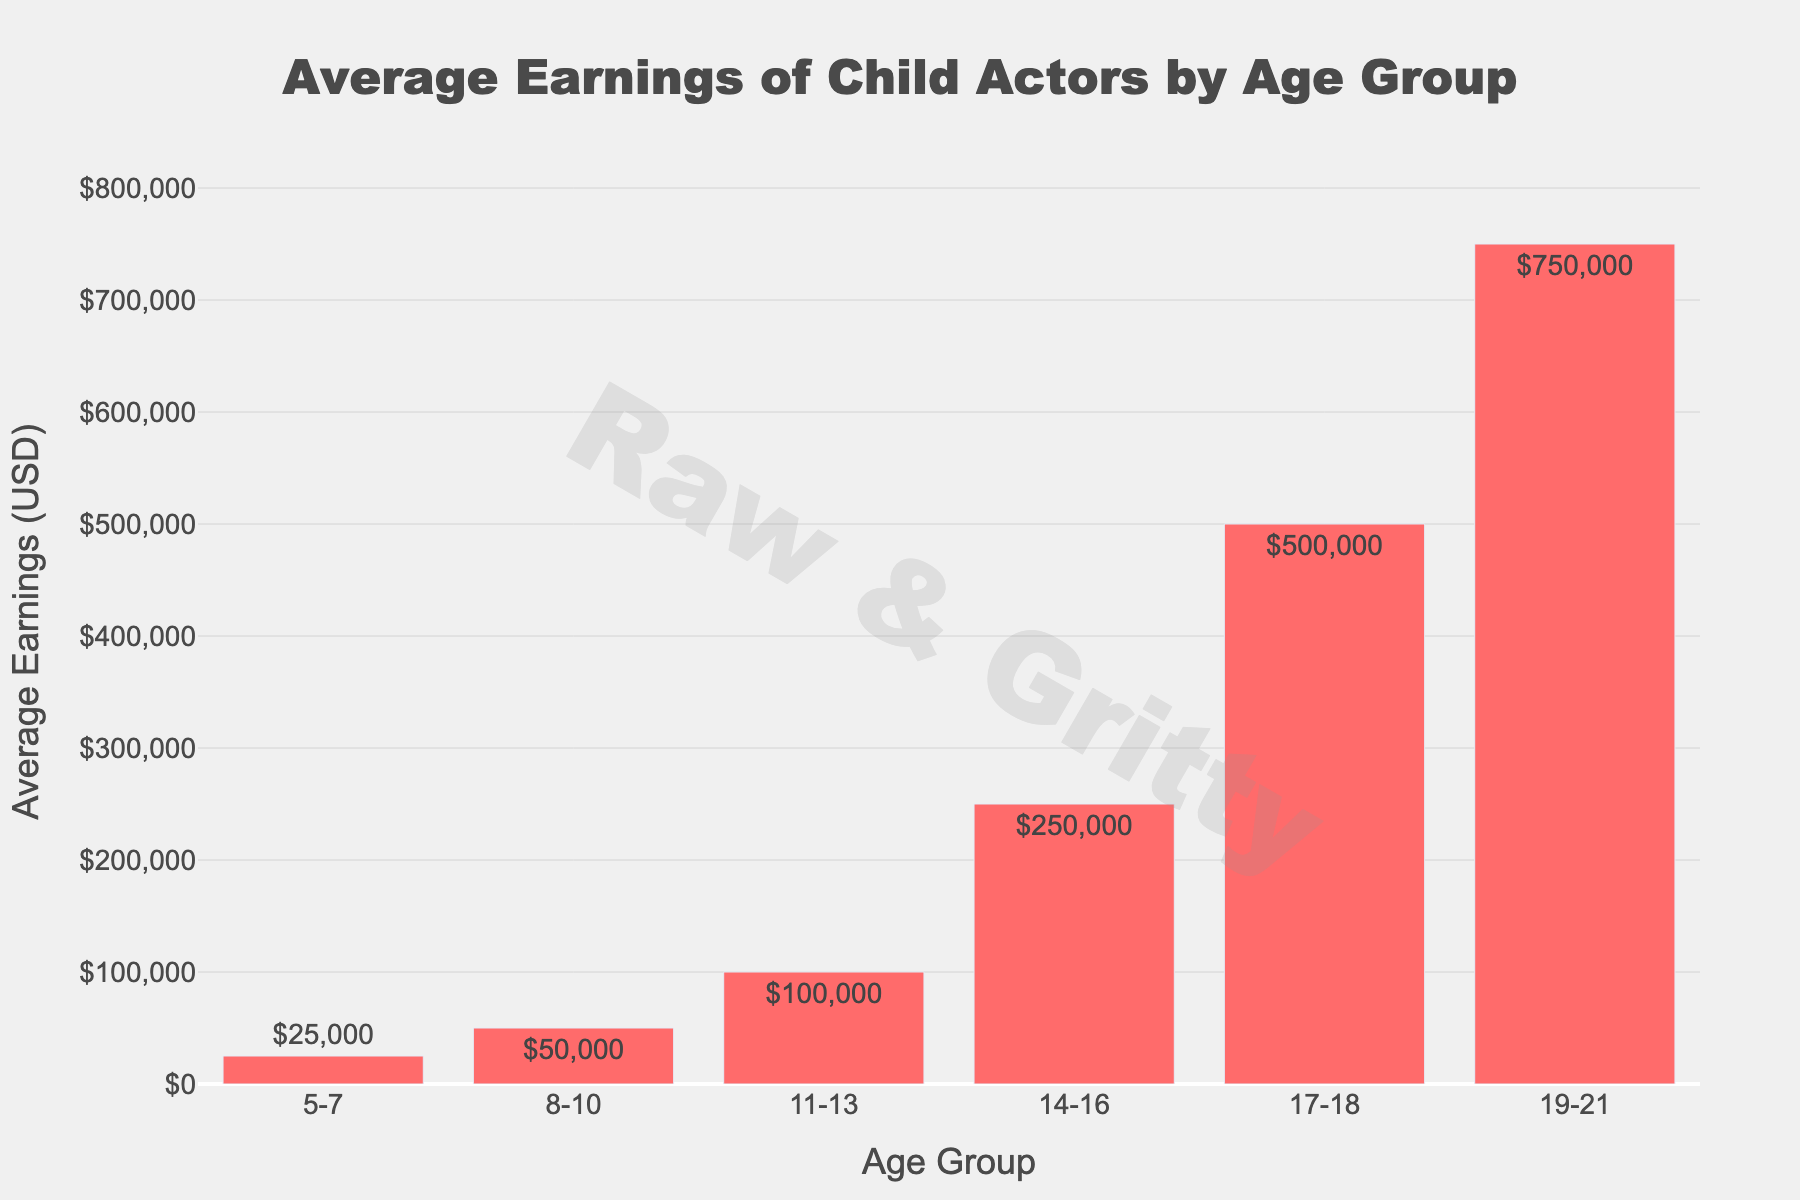Which age group has the highest average earnings? Look for the bar with the greatest height on the figure; the highest bar represents the age group with the highest earnings.
Answer: 19-21 Which age group has the lowest average earnings? Observe the bars and identify the shortest one; the shortest bar corresponds to the age group with the lowest earnings.
Answer: 5-7 How much do average earnings increase from the 5-7 age group to the 8-10 age group? Subtract the average earnings of the 5-7 age group from the average earnings of the 8-10 age group ($50,000 - $25,000).
Answer: $25,000 What is the average earnings difference between the 11-13 and 14-16 age groups? Subtract the average earnings of the 11-13 age group from the average earnings of the 14-16 age group ($250,000 - $100,000).
Answer: $150,000 Which two consecutive age groups show the largest increase in average earnings? Compare the differences between each pair of consecutive age groups and identify the largest one (check differences: $25,000, $50,000, $150,000, $250,000, $250,000).
Answer: 17-18 to 19-21 What percentage increase in average earnings occurs from the 14-16 age group to the 17-18 age group? Calculate the percentage increase by subtracting the 14-16 earnings from the 17-18 earnings, then dividing by the 14-16 earnings, and finally multiplying by 100 ((($500,000 - $250,000) / $250,000) * 100).
Answer: 100% In the given data, what is the total average earnings across all age groups combined? Sum the average earnings for all age groups ($25,000 + $50,000 + $100,000 + $250,000 + $500,000 + $750,000).
Answer: $1,675,000 How do the average earnings of the 8-10 age group compare to those of the 11-13 age group? Compare the numerical values: $50,000 for 8-10 and $100,000 for 11-13 (8-10 < 11-13).
Answer: 8-10 earnings are lower What is the ratio of average earnings of the 14-16 age group compared to the 5-7 age group? Divide the average earnings of the 14-16 age group by the average earnings of the 5-7 age group ($250,000 / $25,000).
Answer: 10:1 If the average earnings doubled for each age group in the given data, what would be the new earnings for the 11-13 age group? Multiply the current average earnings of the 11-13 age group by 2 ($100,000 * 2).
Answer: $200,000 